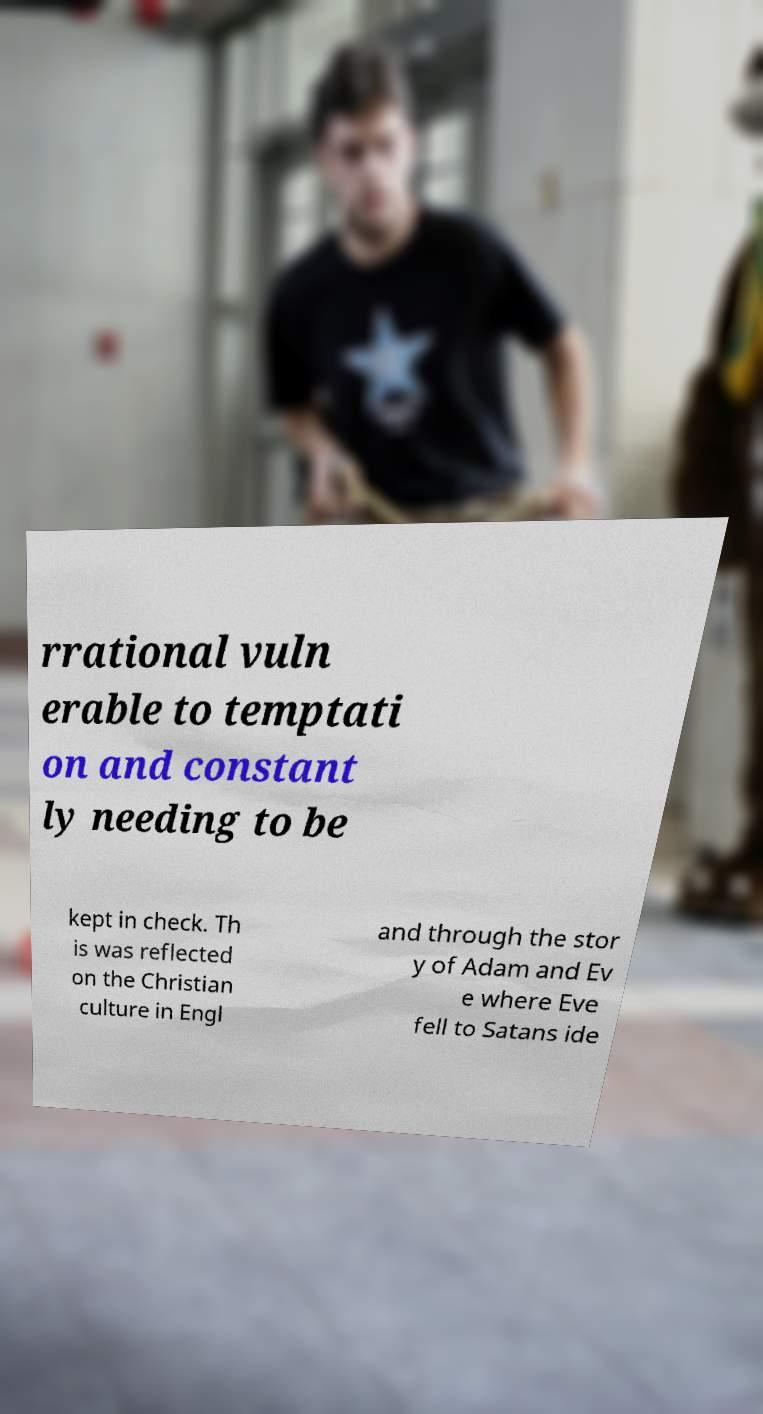Can you accurately transcribe the text from the provided image for me? rrational vuln erable to temptati on and constant ly needing to be kept in check. Th is was reflected on the Christian culture in Engl and through the stor y of Adam and Ev e where Eve fell to Satans ide 